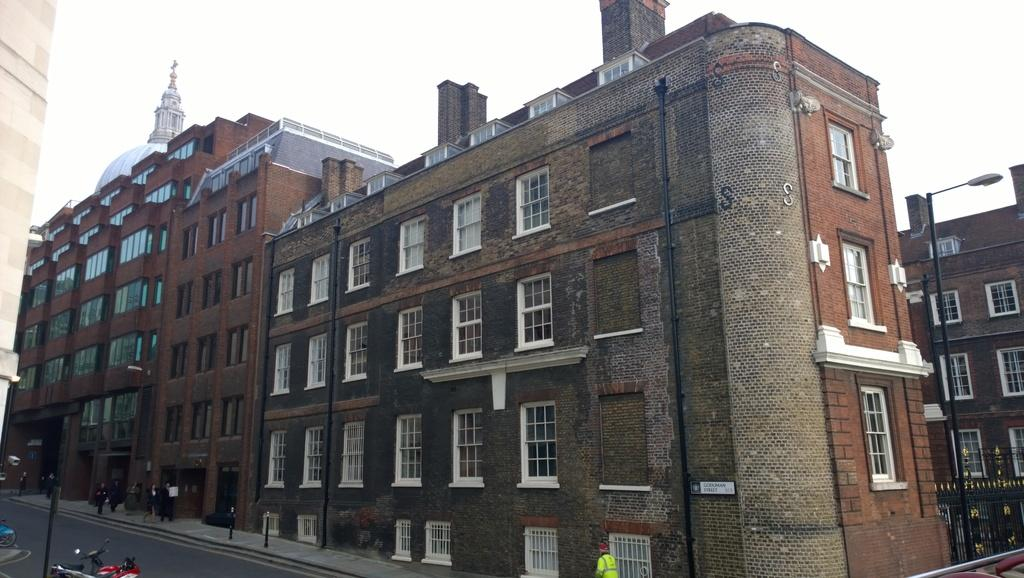What type of structures can be seen in the image? There are buildings in the image. What else can be seen in the image besides buildings? There are poles, people, a board, a road, vehicles, and the sky visible in the background. What might be used for displaying information or advertisements in the image? The board in the image might be used for displaying information or advertisements. What type of transportation is visible in the image? Vehicles are visible in the image. What time is displayed on the clock in the image? There is no clock present in the image. What type of club can be seen in the image? There is no club present in the image. 